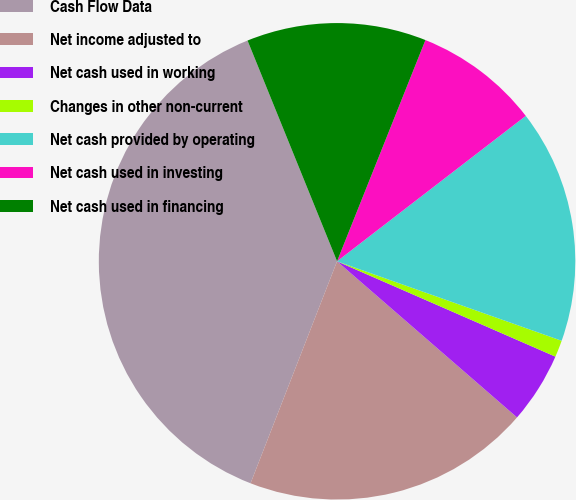Convert chart. <chart><loc_0><loc_0><loc_500><loc_500><pie_chart><fcel>Cash Flow Data<fcel>Net income adjusted to<fcel>Net cash used in working<fcel>Changes in other non-current<fcel>Net cash provided by operating<fcel>Net cash used in investing<fcel>Net cash used in financing<nl><fcel>37.95%<fcel>19.54%<fcel>4.82%<fcel>1.14%<fcel>15.86%<fcel>8.5%<fcel>12.18%<nl></chart> 